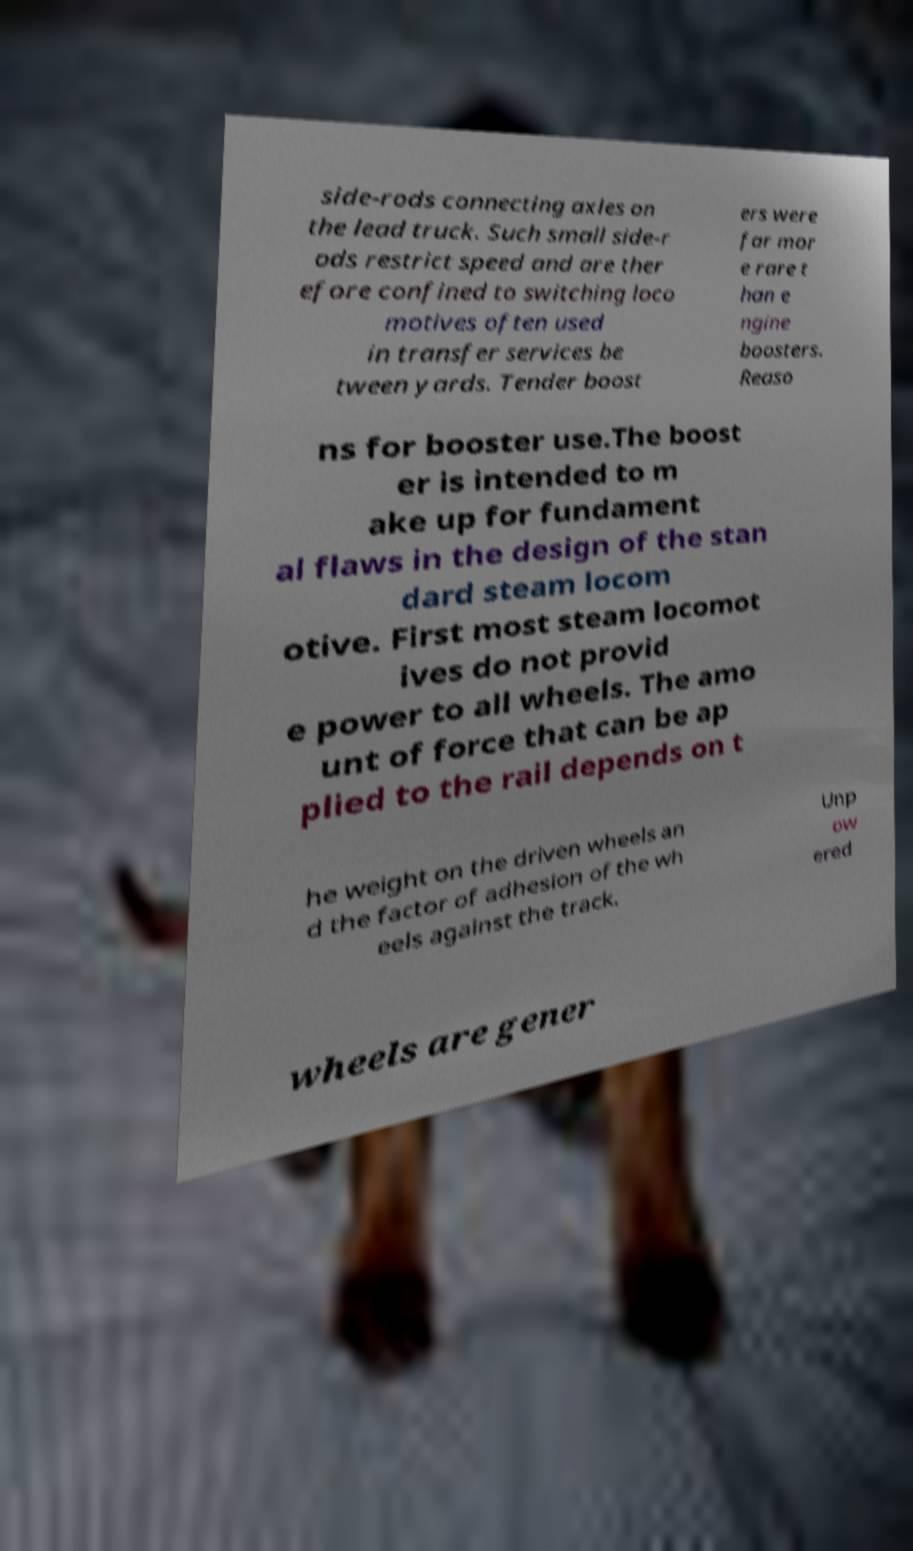For documentation purposes, I need the text within this image transcribed. Could you provide that? side-rods connecting axles on the lead truck. Such small side-r ods restrict speed and are ther efore confined to switching loco motives often used in transfer services be tween yards. Tender boost ers were far mor e rare t han e ngine boosters. Reaso ns for booster use.The boost er is intended to m ake up for fundament al flaws in the design of the stan dard steam locom otive. First most steam locomot ives do not provid e power to all wheels. The amo unt of force that can be ap plied to the rail depends on t he weight on the driven wheels an d the factor of adhesion of the wh eels against the track. Unp ow ered wheels are gener 